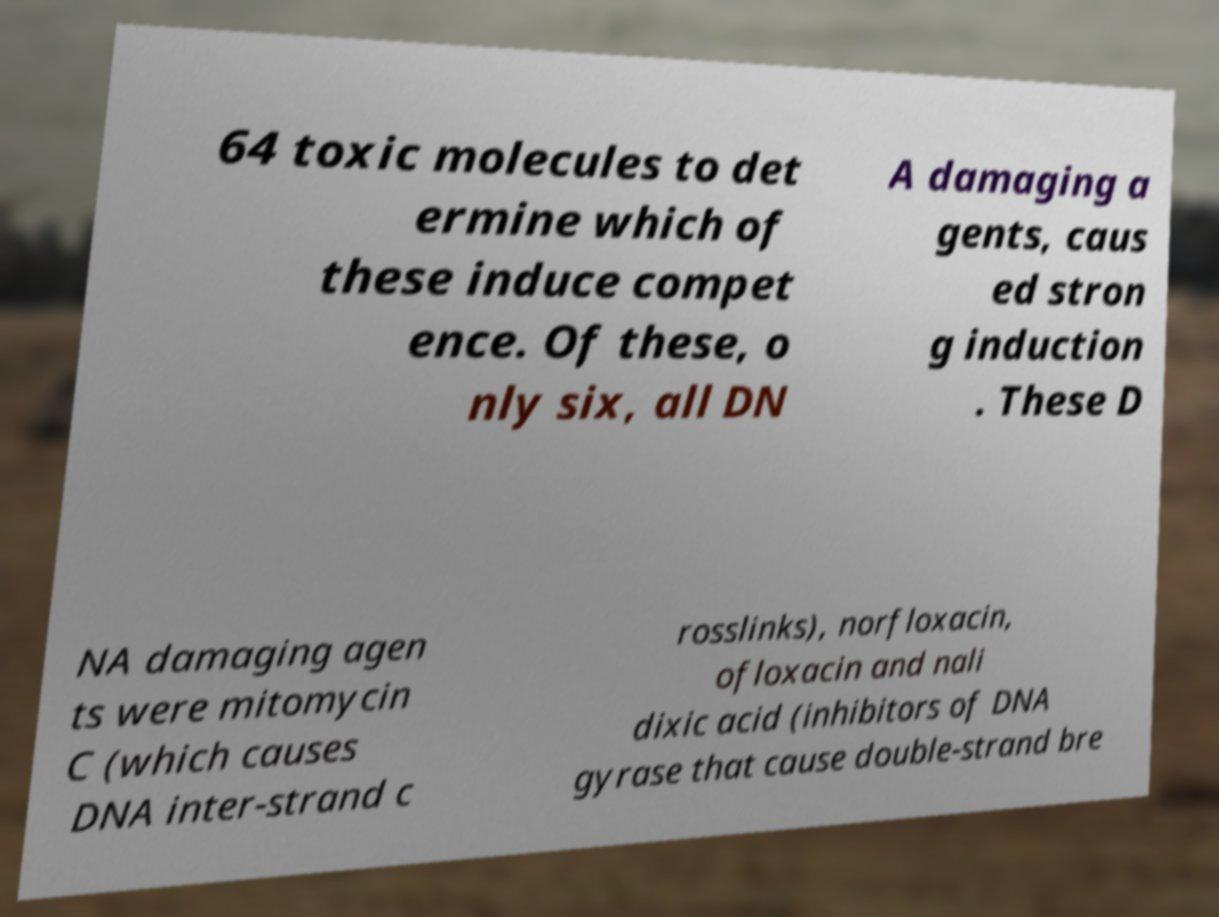Can you read and provide the text displayed in the image?This photo seems to have some interesting text. Can you extract and type it out for me? 64 toxic molecules to det ermine which of these induce compet ence. Of these, o nly six, all DN A damaging a gents, caus ed stron g induction . These D NA damaging agen ts were mitomycin C (which causes DNA inter-strand c rosslinks), norfloxacin, ofloxacin and nali dixic acid (inhibitors of DNA gyrase that cause double-strand bre 